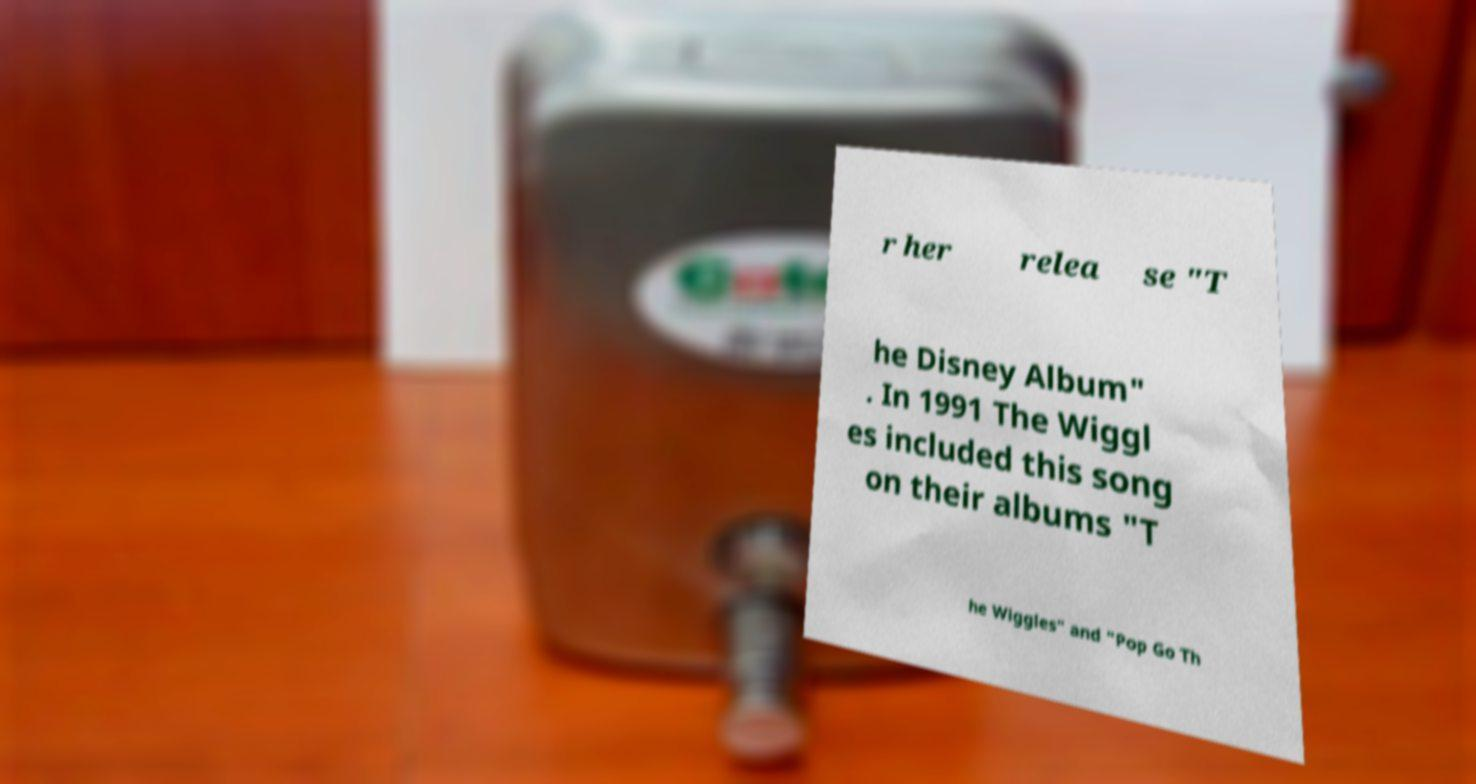For documentation purposes, I need the text within this image transcribed. Could you provide that? r her relea se "T he Disney Album" . In 1991 The Wiggl es included this song on their albums "T he Wiggles" and "Pop Go Th 